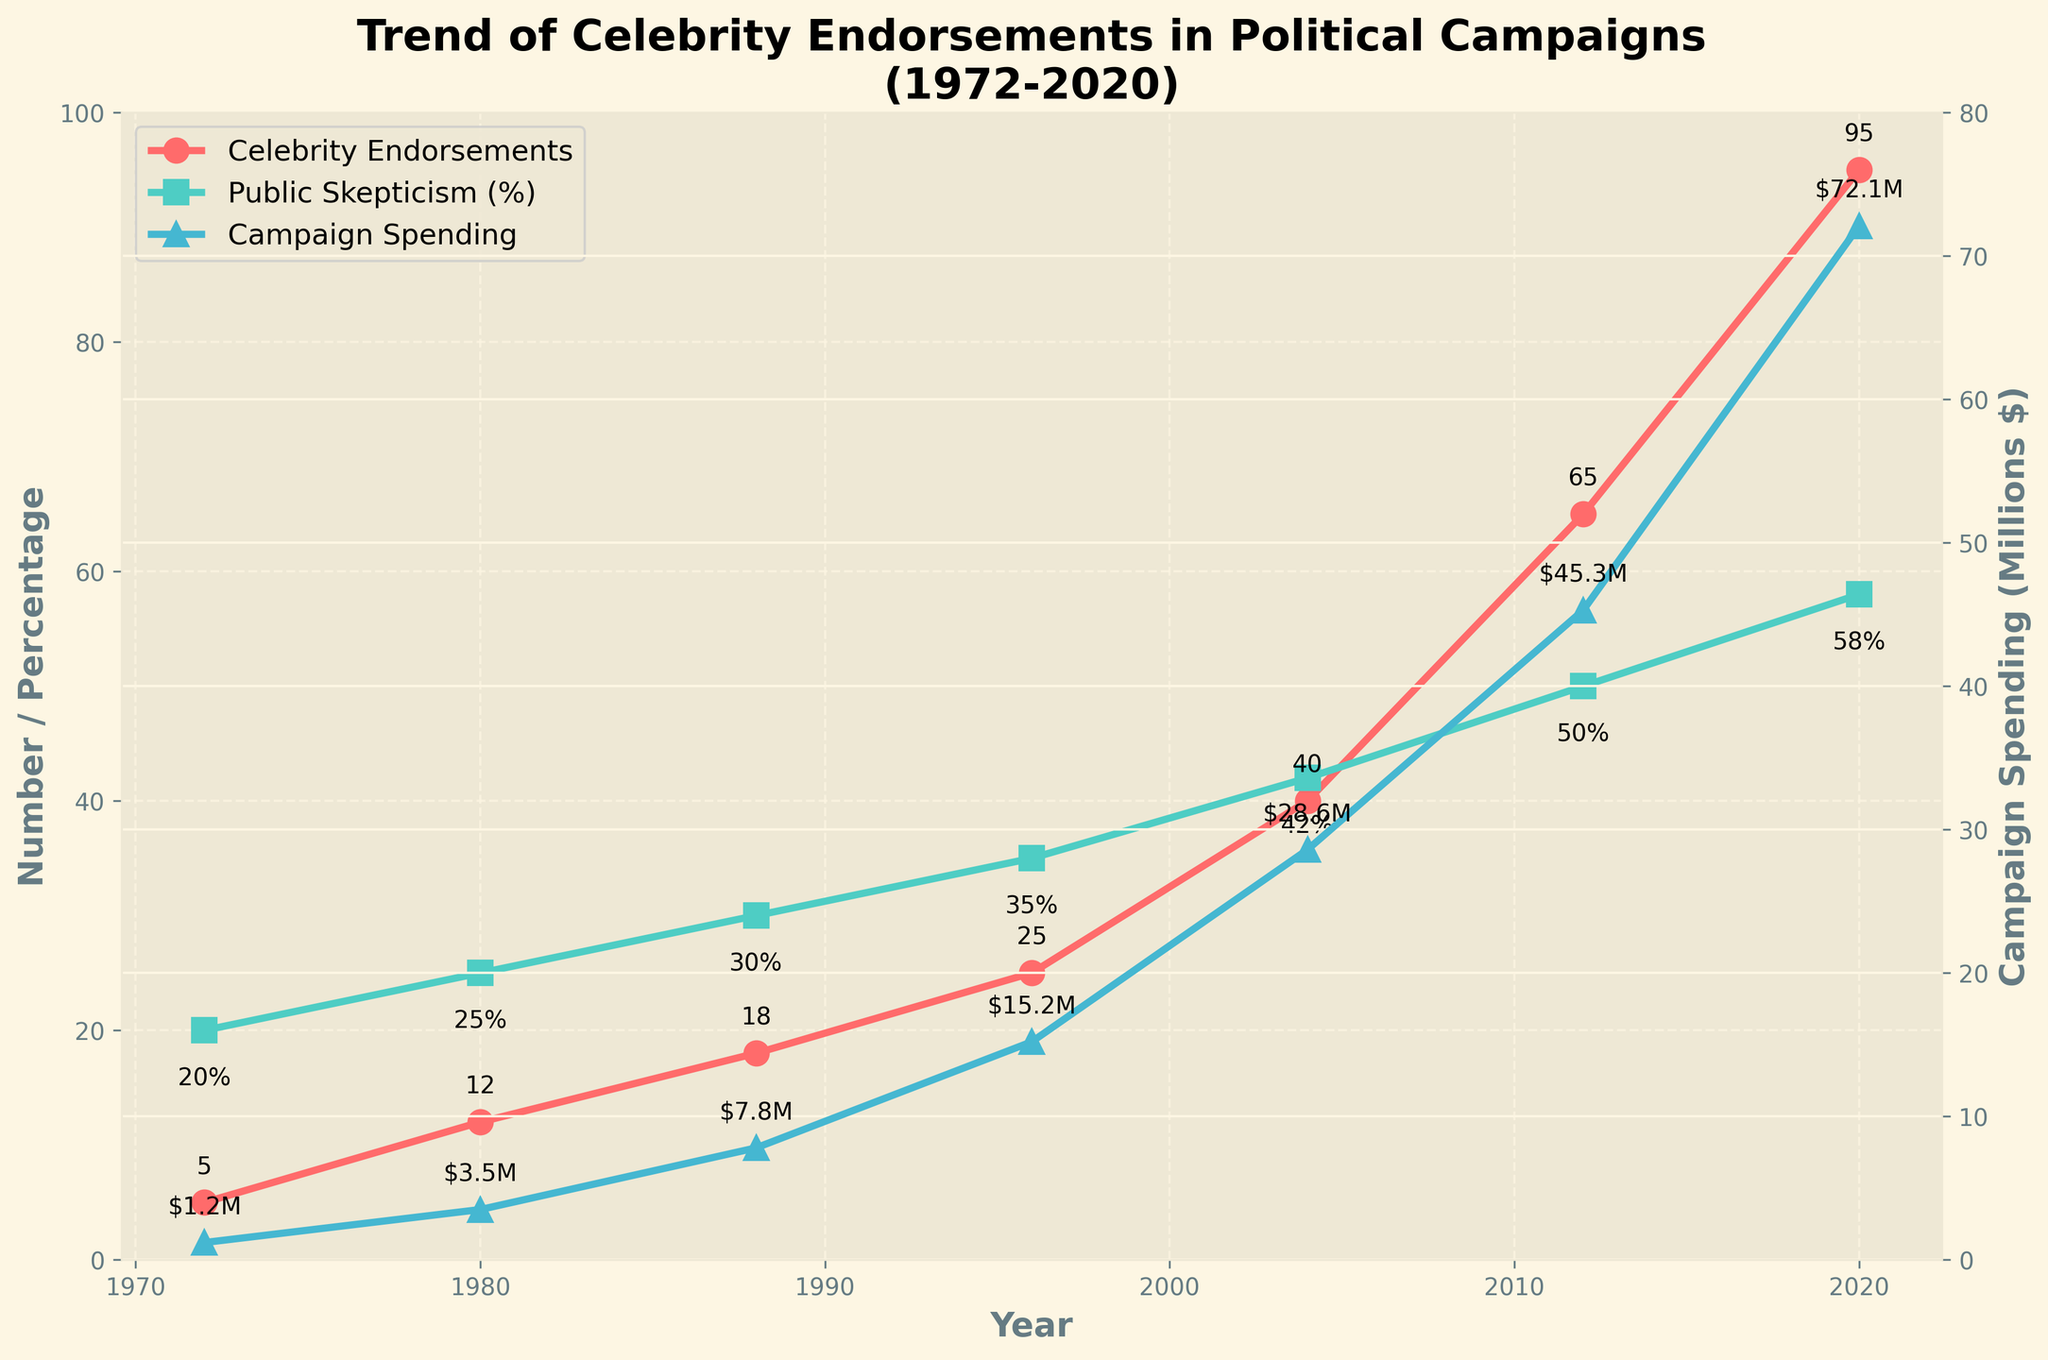What trend is noticeable in the number of celebrity endorsements from 1972 to 2020? The graph shows a clear upward trend in the number of celebrity endorsements in political campaigns from 1972 (5 endorsements) to 2020 (95 endorsements).
Answer: Increasing How has public skepticism changed over the years, and especially in recent decades? Public skepticism has steadily increased from 20% in 1972 to 58% in 2020.
Answer: Increased Compare the effectiveness rating in 1972 and 2020. In 1972, the effectiveness rating was 6.5, whereas in 2020, it dropped to 4.3, indicating a decrease in perceived effectiveness over time.
Answer: Decreased What is the relationship between campaign spending on endorsements and the number of endorsements? Both campaign spending and the number of endorsements have increased significantly over time. Campaign spending rose from $1.2 million in 1972 to $72.1 million in 2020, while endorsements increased from 5 to 95.
Answer: Both increased Which had the sharpest increase: celebrity endorsements, public skepticism, or campaign spending? Campaign spending showed the sharpest increase, rising from $1.2 million in 1972 to $72.1 million in 2020.
Answer: Campaign spending How do the trends in public skepticism and campaign spending on endorsements compare? While both show upward trends, campaign spending increased much more steeply than public skepticism. Skepticism rose from 20% to 58%, while spending increased from $1.2 million to $72.1 million.
Answer: Campaign spending increased more steeply In what year did the number of celebrity endorsements surpass 50? The number of celebrity endorsements surpassed 50 in the year 2012.
Answer: 2012 What is the biggest single-year increase in public skepticism shown in the figure? The most significant increase in public skepticism happens between 2004 (42%) and 2012 (50%), an 8% rise.
Answer: 8% (from 2004 to 2012) By how much did campaign spending on endorsements increase from 2004 to 2020? Campaign spending increased from $28.6 million in 2004 to $72.1 million in 2020, a $43.5 million increase.
Answer: $43.5 million How has the perceived effectiveness rating changed from 1988 to 2020? The effectiveness rating has decreased from 5.9 in 1988 to 4.3 in 2020.
Answer: Decreased 